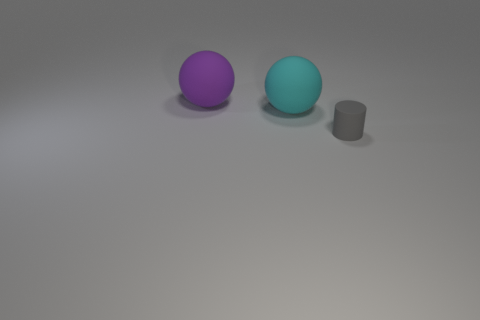Add 2 rubber objects. How many objects exist? 5 Subtract all cylinders. How many objects are left? 2 Subtract all big cyan balls. Subtract all tiny cylinders. How many objects are left? 1 Add 2 cylinders. How many cylinders are left? 3 Add 2 purple objects. How many purple objects exist? 3 Subtract 1 gray cylinders. How many objects are left? 2 